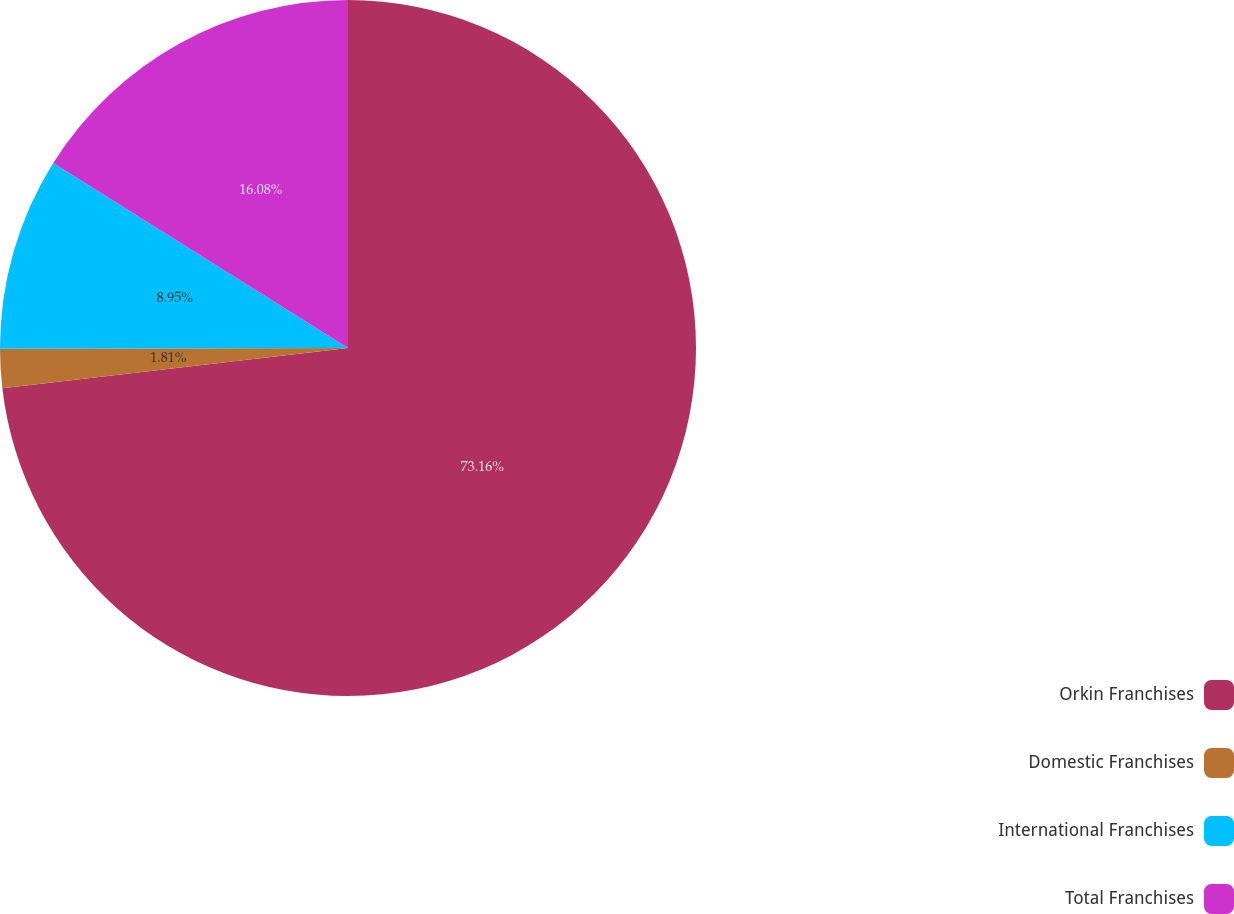Convert chart to OTSL. <chart><loc_0><loc_0><loc_500><loc_500><pie_chart><fcel>Orkin Franchises<fcel>Domestic Franchises<fcel>International Franchises<fcel>Total Franchises<nl><fcel>73.15%<fcel>1.81%<fcel>8.95%<fcel>16.08%<nl></chart> 